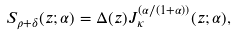Convert formula to latex. <formula><loc_0><loc_0><loc_500><loc_500>S _ { \rho + \delta } ( z ; \alpha ) = \Delta ( z ) J _ { \kappa } ^ { ( \alpha / ( 1 + \alpha ) ) } ( z ; \alpha ) ,</formula> 